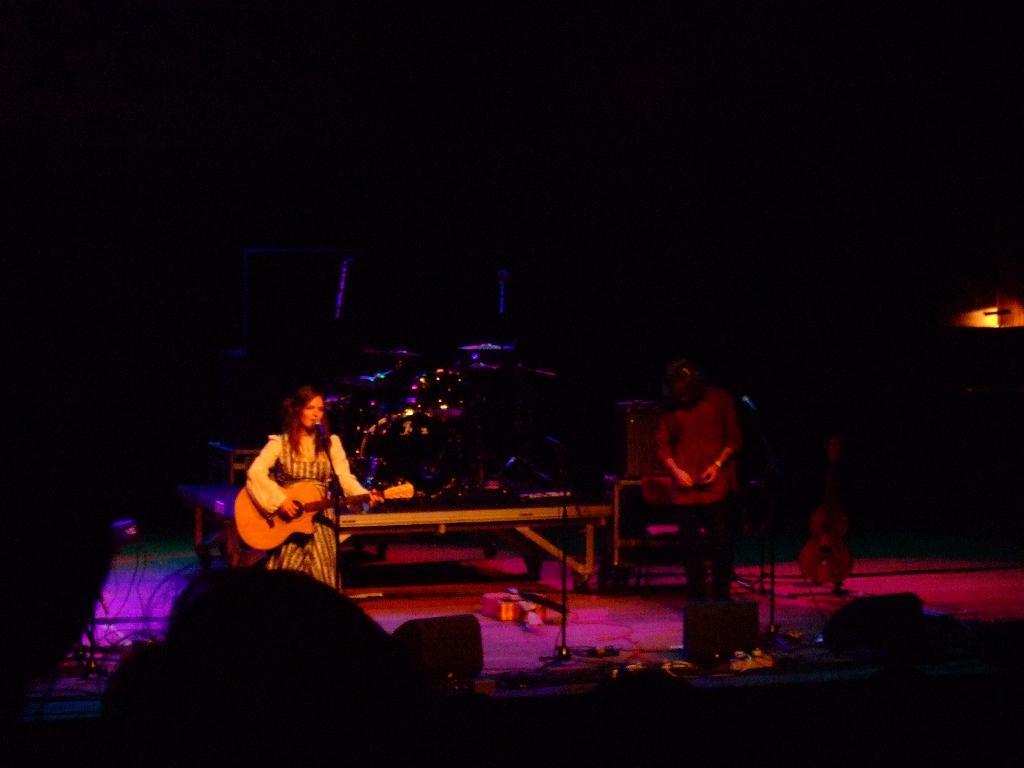In one or two sentences, can you explain what this image depicts? In this picture we can see one woman and person where woman is holding guitar in her hand and playing it and singing on mic and in background we can see table, lights and it is dark. 